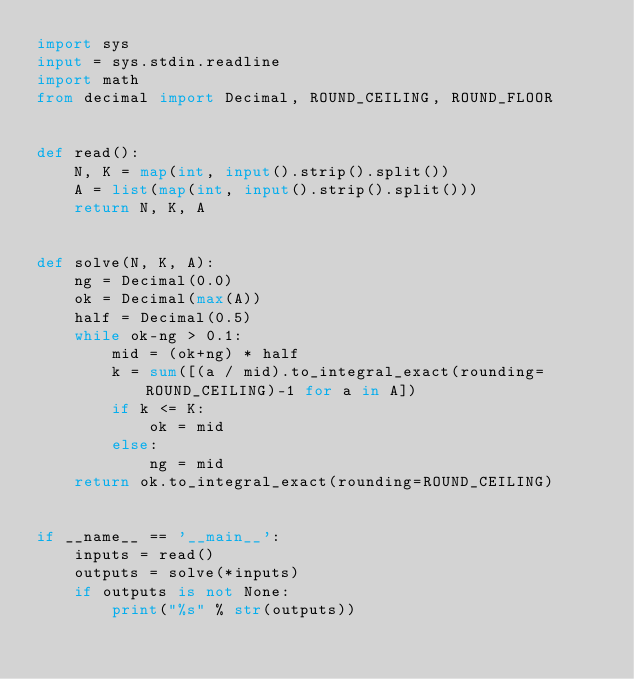<code> <loc_0><loc_0><loc_500><loc_500><_Python_>import sys
input = sys.stdin.readline
import math
from decimal import Decimal, ROUND_CEILING, ROUND_FLOOR


def read():
    N, K = map(int, input().strip().split())
    A = list(map(int, input().strip().split()))
    return N, K, A


def solve(N, K, A):
    ng = Decimal(0.0)
    ok = Decimal(max(A))
    half = Decimal(0.5)
    while ok-ng > 0.1:
        mid = (ok+ng) * half
        k = sum([(a / mid).to_integral_exact(rounding=ROUND_CEILING)-1 for a in A])
        if k <= K:
            ok = mid
        else:
            ng = mid
    return ok.to_integral_exact(rounding=ROUND_CEILING)


if __name__ == '__main__':
    inputs = read()
    outputs = solve(*inputs)
    if outputs is not None:
        print("%s" % str(outputs))
</code> 